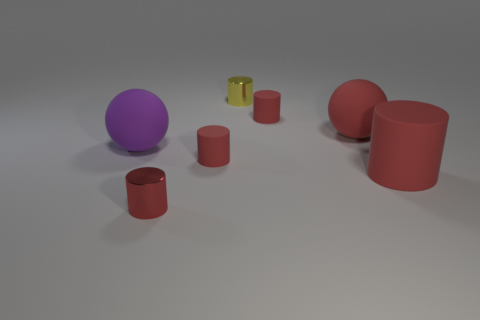What colors and shapes are visible in the image? The image features several objects with different colors and shapes, including red cylinders, a purple sphere, and a green and yellow mug. The shapes include cylinders, a sphere, and a mug with a handle. Which object stands out the most in the image and why? The purple sphere stands out the most due to its vibrant color and spherical shape, which contrasts with the predominantly red cylindrical objects and the comparatively dull setting. 